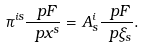<formula> <loc_0><loc_0><loc_500><loc_500>\pi ^ { i s } \frac { \ p F } { \ p x ^ { s } } = A ^ { i } _ { s } \frac { \ p F } { \ p \xi _ { s } } .</formula> 